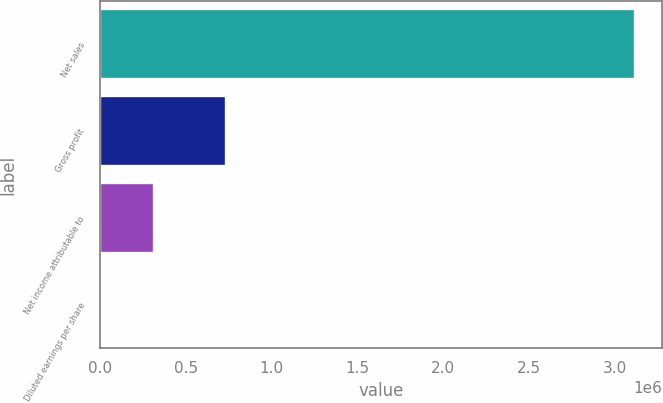<chart> <loc_0><loc_0><loc_500><loc_500><bar_chart><fcel>Net sales<fcel>Gross profit<fcel>Net income attributable to<fcel>Diluted earnings per share<nl><fcel>3.11914e+06<fcel>735349<fcel>311915<fcel>1.75<nl></chart> 